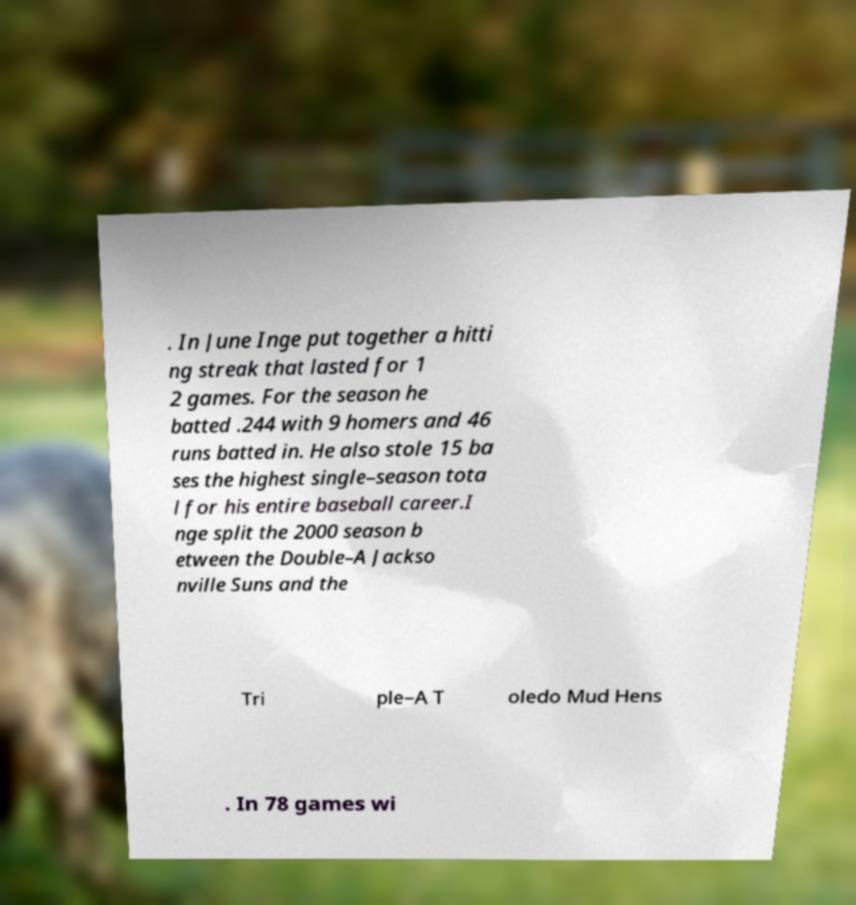Please read and relay the text visible in this image. What does it say? . In June Inge put together a hitti ng streak that lasted for 1 2 games. For the season he batted .244 with 9 homers and 46 runs batted in. He also stole 15 ba ses the highest single–season tota l for his entire baseball career.I nge split the 2000 season b etween the Double–A Jackso nville Suns and the Tri ple–A T oledo Mud Hens . In 78 games wi 